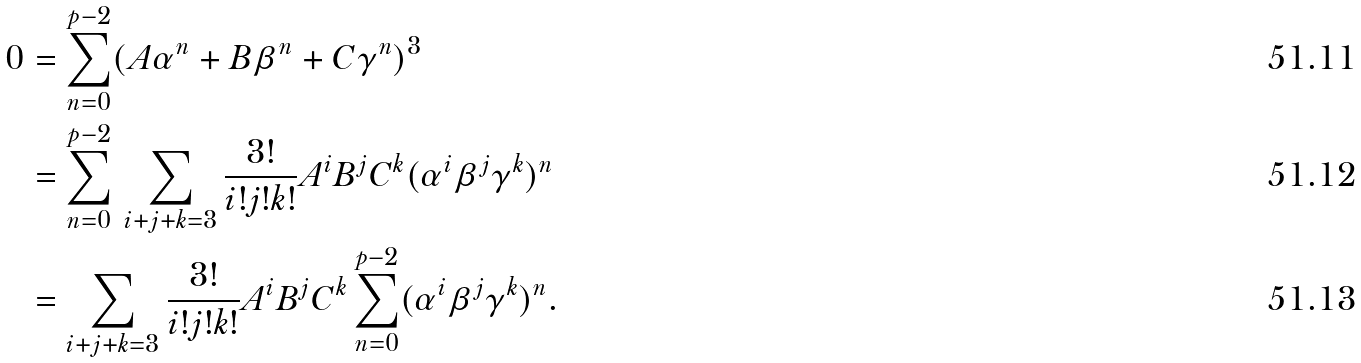Convert formula to latex. <formula><loc_0><loc_0><loc_500><loc_500>0 & = \sum _ { n = 0 } ^ { p - 2 } ( A \alpha ^ { n } + B \beta ^ { n } + C \gamma ^ { n } ) ^ { 3 } \\ & = \sum _ { n = 0 } ^ { p - 2 } \, \sum _ { i + j + k = 3 } \frac { 3 ! } { i ! j ! k ! } A ^ { i } B ^ { j } C ^ { k } ( \alpha ^ { i } \beta ^ { j } \gamma ^ { k } ) ^ { n } \\ & = \sum _ { i + j + k = 3 } \frac { 3 ! } { i ! j ! k ! } A ^ { i } B ^ { j } C ^ { k } \sum _ { n = 0 } ^ { p - 2 } ( \alpha ^ { i } \beta ^ { j } \gamma ^ { k } ) ^ { n } .</formula> 